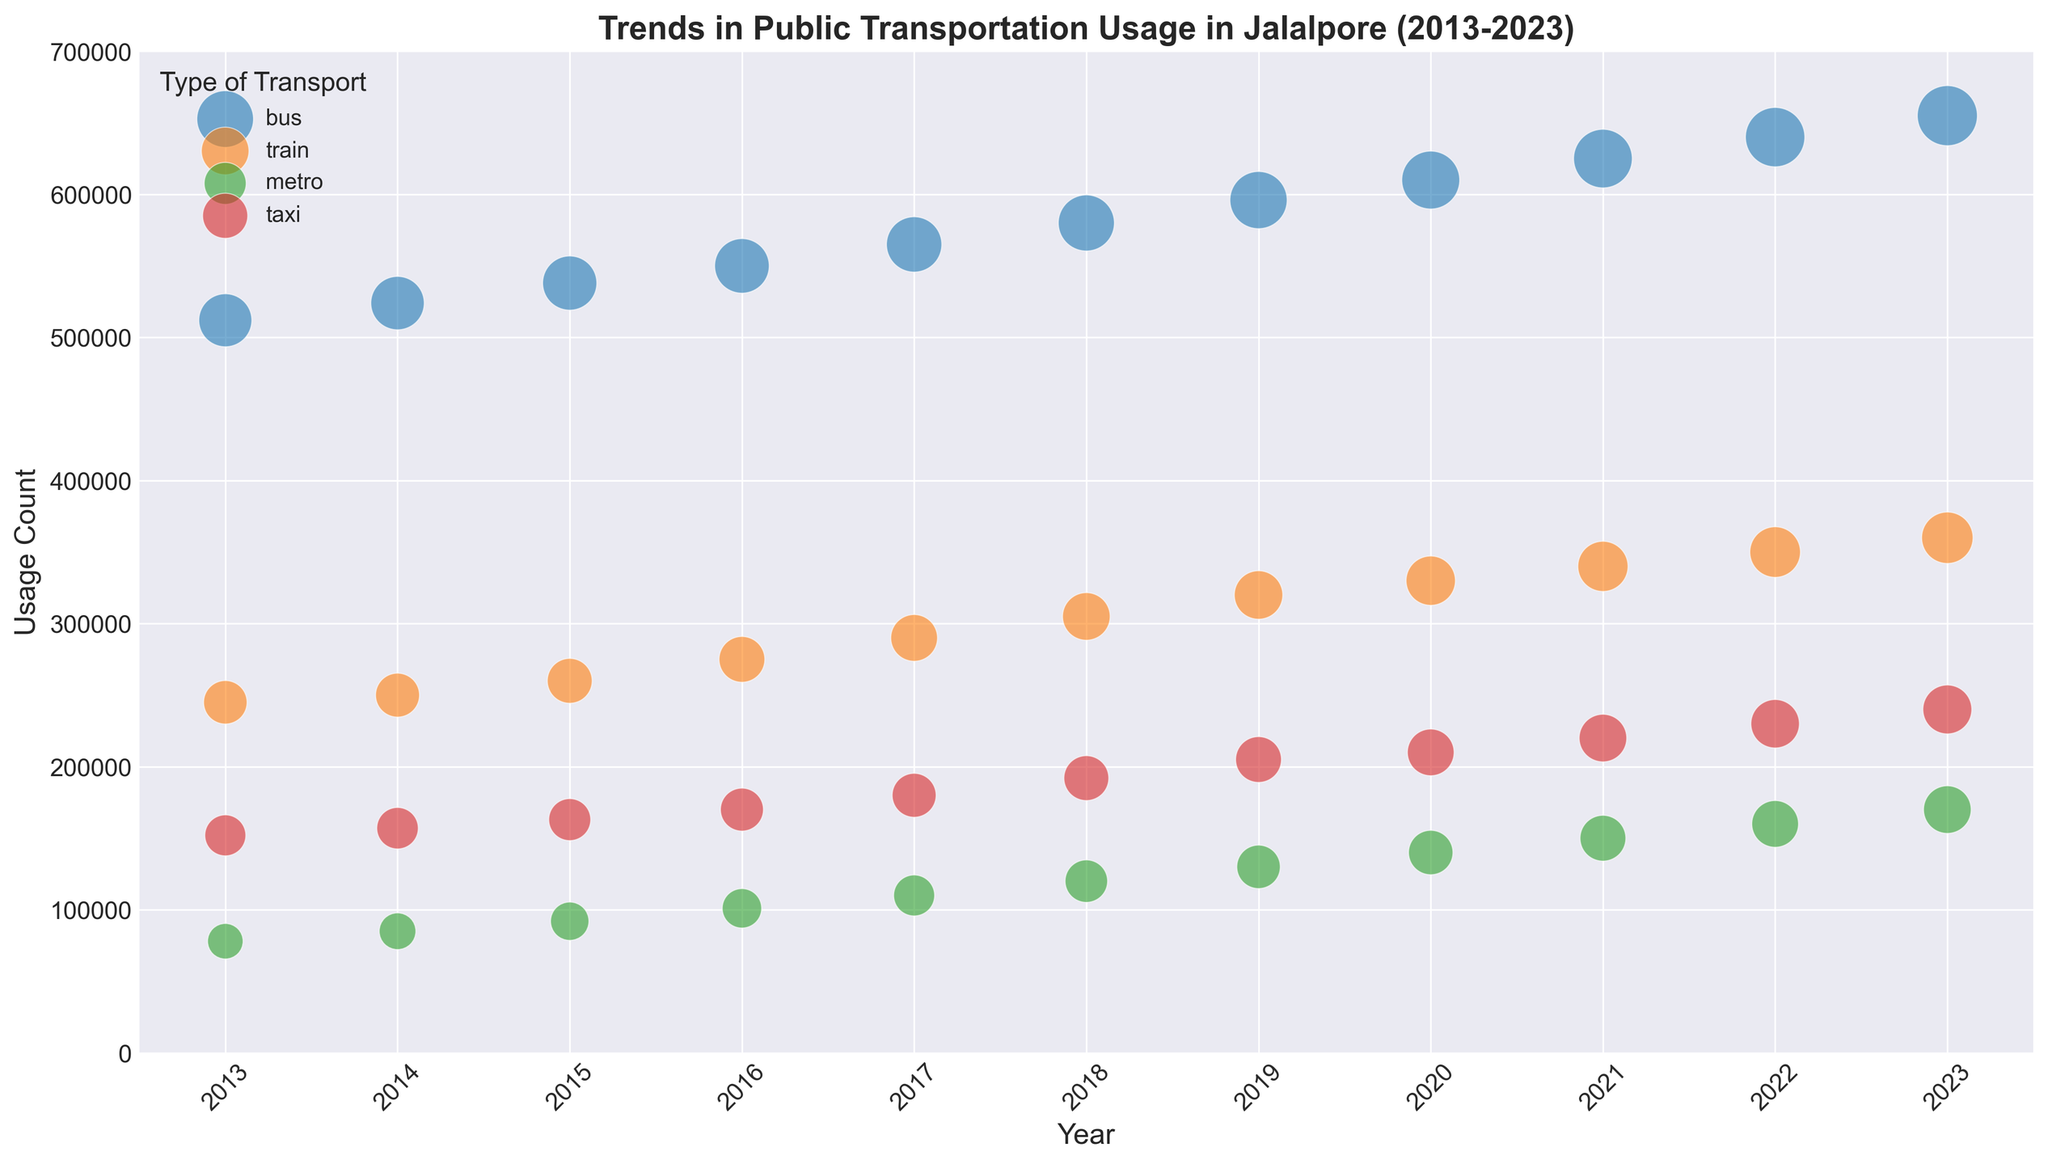What's the most popular type of transportation in 2023 based on the usage count? Look at the size of the bubbles and the usage count axis for 2023. The 'bus' category has the largest bubble with 655,000 usage count.
Answer: Bus By how much has the popularity score of metro increased between 2013 and 2023? Check the popularity scores for the metro in both 2013 and 2023. It increased from 30 in 2013 to 54 in 2023. The difference is 54 - 30 = 24.
Answer: 24 Which year did the train usage count first surpass 300,000? Locate the train usage count on the vertical axis. The year when the bubble's height surpasses 300,000 is 2018.
Answer: 2018 What is the average popularity score of buses from 2013 to 2023? Calculate the mean of the popularity scores for buses across all years: (67 + 68 + 70 + 71 + 73 + 75 + 78 + 80 + 82 + 84 + 86) / 11. Sum is 834, so the average is 834 / 11 = 75.82.
Answer: 75.82 In which year was the difference between the bus and train usage count the largest? Compare the vertical height difference of bus and train bubbles each year. The greatest difference is in 2023 (655,000 for bus vs. 360,000 for train, difference is 295,000).
Answer: 2023 Which type of transportation had a consistent increase in popularity score every single year? Examine the trend in the size of the bubbles year by year for each type. Both 'bus' and 'train' show consistent increases, but 'bus' has higher scores. However, both 'bus' and 'train' increased consistently.
Answer: Bus, Train How many types of transportation exceeded 100,000 usage count in 2016? Look at the 2016 bubbles and their positions above the 100,000 mark on the vertical axis. The types that exceed 100,000 are bus (550,000), train (275,000), metro (101,000), and taxi (170,000).
Answer: Four What is the total train usage count from 2013 to 2023? Sum the number of train usage counts for all years: 245,000 + 250,000 + 260,000 + 275,000 + 290,000 + 305,000 + 320,000 + 330,000 + 340,000 + 350,000 + 360,000. Total is 3,325,000.
Answer: 3,325,000 What trend do you observe in the metro’s popularity score from 2013 to 2023? The metro's bubble size increases each year, indicating a steady rise in popularity score from 30 in 2013 to 54 in 2023.
Answer: Increasing 